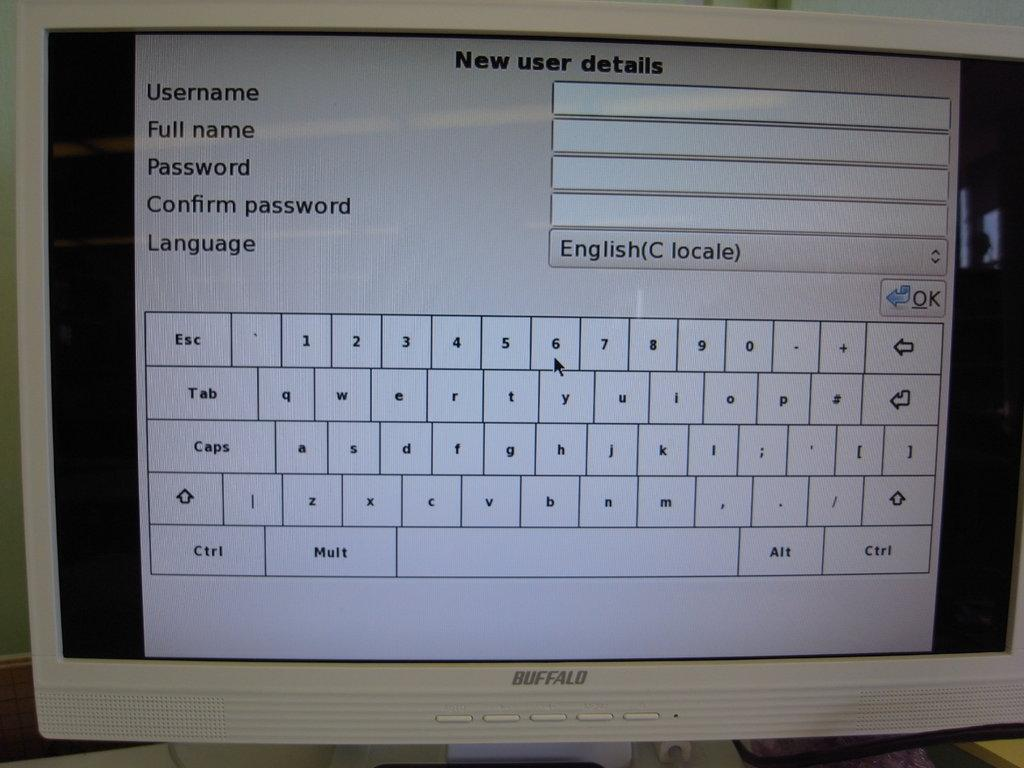<image>
Create a compact narrative representing the image presented. A window that says new user details has spots to type in a username and a password. 